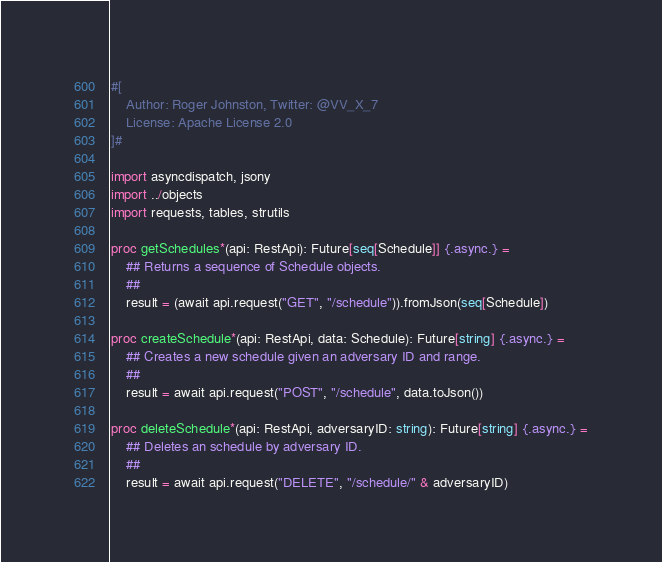Convert code to text. <code><loc_0><loc_0><loc_500><loc_500><_Nim_>#[
    Author: Roger Johnston, Twitter: @VV_X_7
    License: Apache License 2.0
]#

import asyncdispatch, jsony
import ../objects
import requests, tables, strutils

proc getSchedules*(api: RestApi): Future[seq[Schedule]] {.async.} =
    ## Returns a sequence of Schedule objects.
    ## 
    result = (await api.request("GET", "/schedule")).fromJson(seq[Schedule])

proc createSchedule*(api: RestApi, data: Schedule): Future[string] {.async.} =
    ## Creates a new schedule given an adversary ID and range.
    ## 
    result = await api.request("POST", "/schedule", data.toJson())

proc deleteSchedule*(api: RestApi, adversaryID: string): Future[string] {.async.} =
    ## Deletes an schedule by adversary ID.
    ## 
    result = await api.request("DELETE", "/schedule/" & adversaryID)</code> 